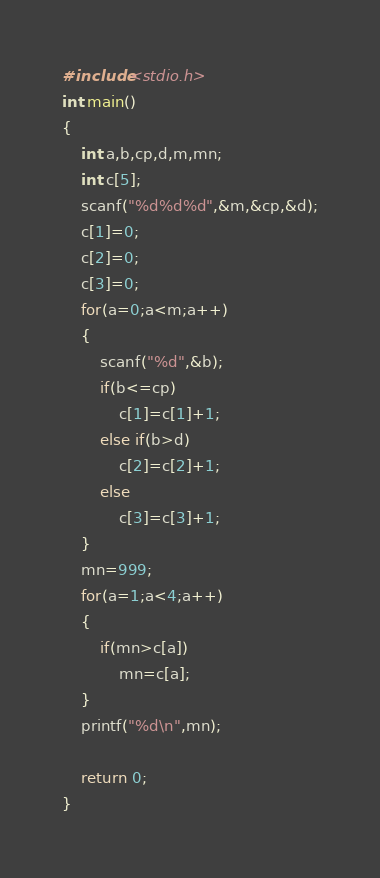<code> <loc_0><loc_0><loc_500><loc_500><_C_>#include<stdio.h>
int main()
{
    int a,b,cp,d,m,mn;
    int c[5];
    scanf("%d%d%d",&m,&cp,&d);
    c[1]=0;
    c[2]=0;
    c[3]=0;
    for(a=0;a<m;a++)
    {
        scanf("%d",&b);
        if(b<=cp)
            c[1]=c[1]+1;
        else if(b>d)
            c[2]=c[2]+1;
        else
            c[3]=c[3]+1;
    }
    mn=999;
    for(a=1;a<4;a++)
    {
        if(mn>c[a])
            mn=c[a];
    }
    printf("%d\n",mn);
  
    return 0;
}
</code> 